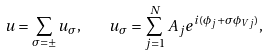Convert formula to latex. <formula><loc_0><loc_0><loc_500><loc_500>u = \sum _ { \sigma = \pm } u _ { \sigma } , \quad u _ { \sigma } = \sum _ { j = 1 } ^ { N } A _ { j } e ^ { i ( \phi _ { j } + \sigma \phi _ { V j } ) } ,</formula> 